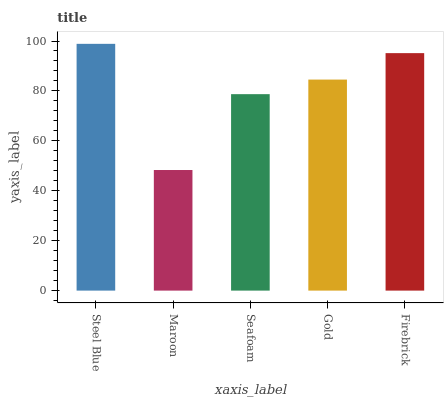Is Maroon the minimum?
Answer yes or no. Yes. Is Steel Blue the maximum?
Answer yes or no. Yes. Is Seafoam the minimum?
Answer yes or no. No. Is Seafoam the maximum?
Answer yes or no. No. Is Seafoam greater than Maroon?
Answer yes or no. Yes. Is Maroon less than Seafoam?
Answer yes or no. Yes. Is Maroon greater than Seafoam?
Answer yes or no. No. Is Seafoam less than Maroon?
Answer yes or no. No. Is Gold the high median?
Answer yes or no. Yes. Is Gold the low median?
Answer yes or no. Yes. Is Seafoam the high median?
Answer yes or no. No. Is Seafoam the low median?
Answer yes or no. No. 